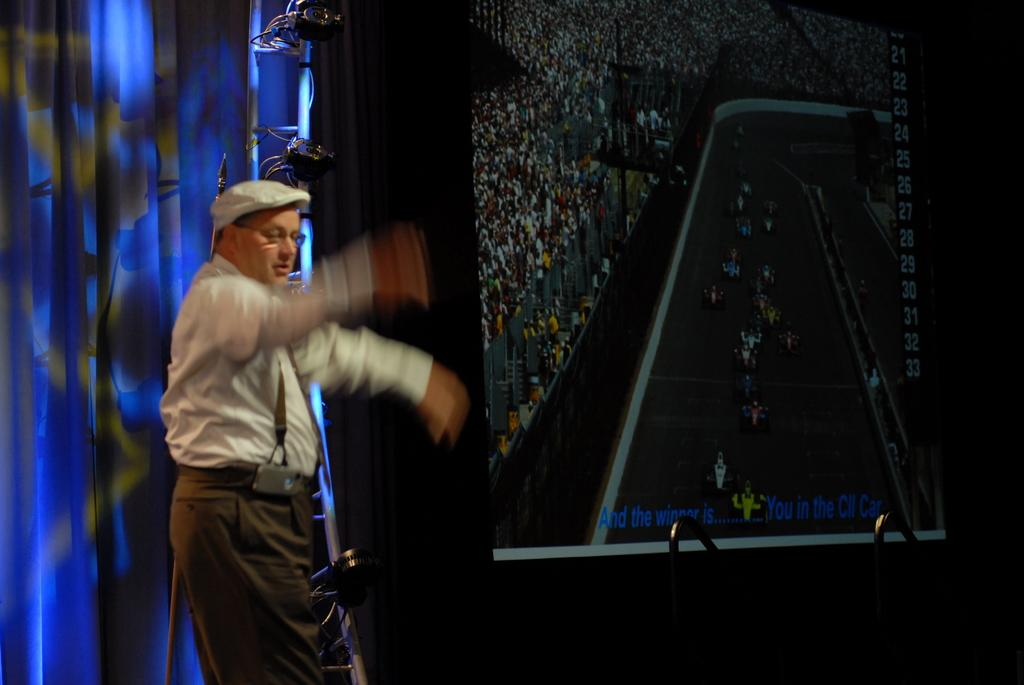Who is present in the image? There is a man in the image. Where is the man located in the image? The man is on the left side of the image. What is the man wearing on his head? The man is wearing a cap. What can be seen on the screen in the image? The facts do not specify what is on the screen, so we cannot answer that question. What type of material are the metal rods made of? The facts do not specify the material of the metal rods, so we cannot answer that question. What type of window treatment is present in the image? There are curtains in the image. What type of grape is being used as a scene prop in the image? There is no grape present in the image, and therefore no such prop can be observed. 